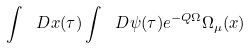<formula> <loc_0><loc_0><loc_500><loc_500>\int \ D x ( \tau ) \int \ D \psi ( \tau ) e ^ { - Q \Omega } \Omega _ { \mu } ( x )</formula> 